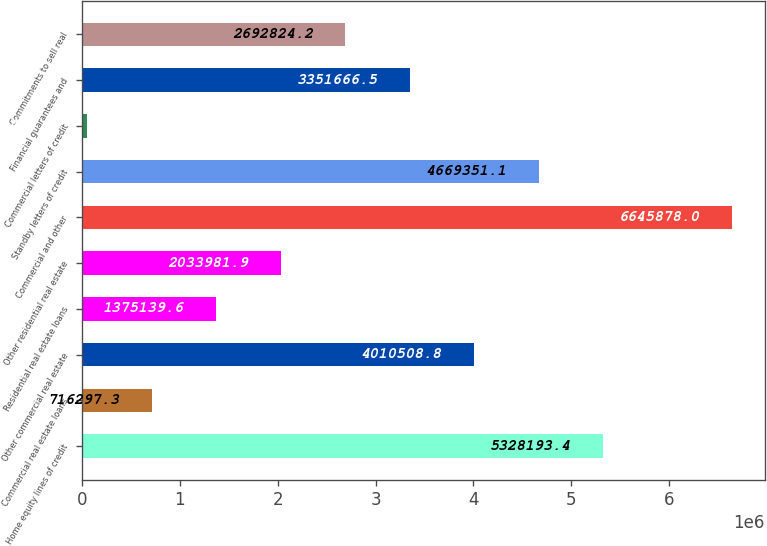Convert chart to OTSL. <chart><loc_0><loc_0><loc_500><loc_500><bar_chart><fcel>Home equity lines of credit<fcel>Commercial real estate loans<fcel>Other commercial real estate<fcel>Residential real estate loans<fcel>Other residential real estate<fcel>Commercial and other<fcel>Standby letters of credit<fcel>Commercial letters of credit<fcel>Financial guarantees and<fcel>Commitments to sell real<nl><fcel>5.32819e+06<fcel>716297<fcel>4.01051e+06<fcel>1.37514e+06<fcel>2.03398e+06<fcel>6.64588e+06<fcel>4.66935e+06<fcel>57455<fcel>3.35167e+06<fcel>2.69282e+06<nl></chart> 